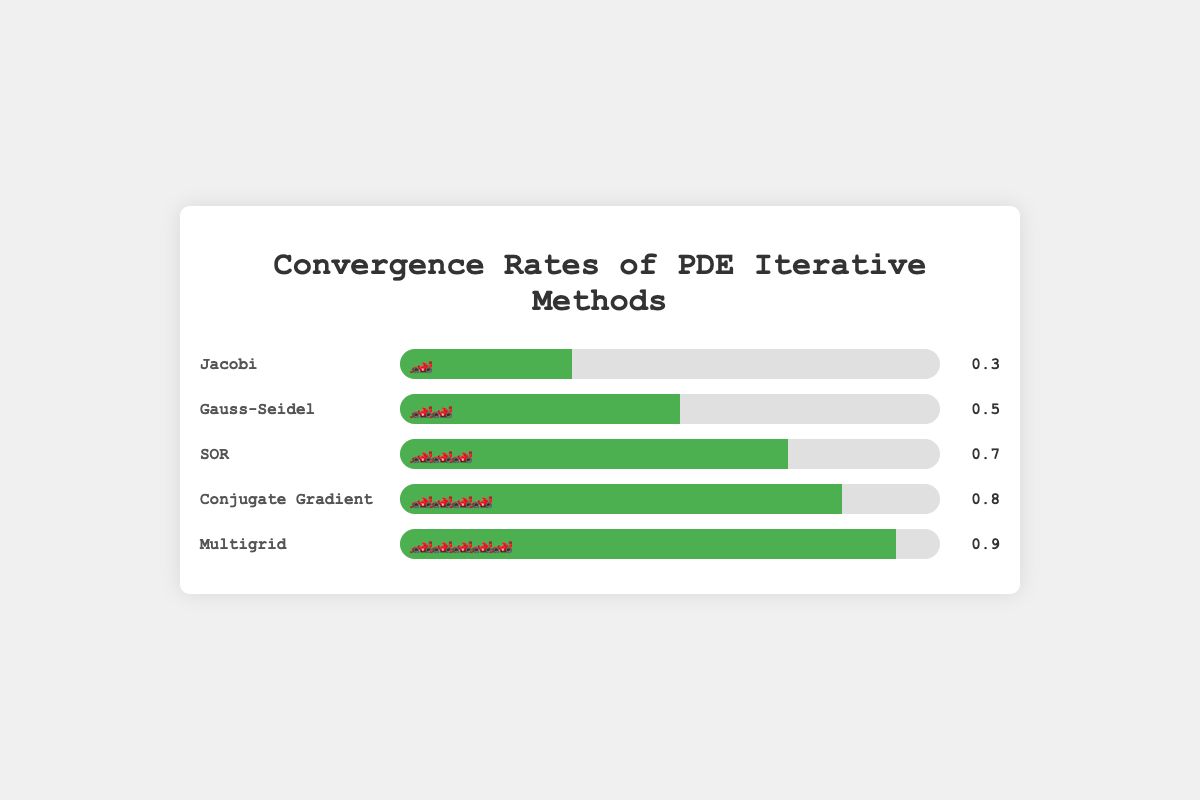Which method has the highest convergence rate? The method with the highest convergence rate is represented by the bar with the most emoji cars and the highest numerical value. The Multigrid method has the highest convergence rate of 0.9, displayed with five emoji cars.
Answer: Multigrid How many methods have a convergence rate of 0.5 or higher? We need to count the methods whose convergence rates are 0.5 or above. Gauss-Seidel (0.5), SOR (0.7), Conjugate Gradient (0.8), and Multigrid (0.9) meet the criteria.
Answer: 4 What is the difference in convergence rate between the SOR method and the Gauss-Seidel method? Subtract the convergence rate of Gauss-Seidel (0.5) from the convergence rate of SOR (0.7): 0.7 - 0.5 = 0.2.
Answer: 0.2 How many emoji cars are used to represent the Conjugate Gradient method? The number of emoji cars can be counted directly from the visual representation. The Conjugate Gradient method is shown with four emoji cars.
Answer: 4 Which method has the slowest convergence rate? The method with the lowest convergence rate will have the fewest emoji cars and the lowest numerical value. Jacobi has the convergence rate of 0.3, the lowest among the methods listed.
Answer: Jacobi What is the total convergence rate of all the methods combined? Add the convergence rates of all the methods: 0.3 (Jacobi) + 0.5 (Gauss-Seidel) + 0.7 (SOR) + 0.8 (Conjugate Gradient) + 0.9 (Multigrid). The total is 3.2.
Answer: 3.2 Which methods have a higher convergence rate than the Jacobi method? Compare the rest of the methods to see which have a convergence rate greater than 0.3. Gauss-Seidel (0.5), SOR (0.7), Conjugate Gradient (0.8), and Multigrid (0.9) all have higher rates.
Answer: Gauss-Seidel, SOR, Conjugate Gradient, Multigrid What is the average convergence rate of all the methods? Sum all the convergence rates (0.3 + 0.5 + 0.7 + 0.8 + 0.9) and divide by the number of methods (5). The sum is 3.2, divided by 5 equals 0.64.
Answer: 0.64 